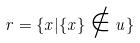<formula> <loc_0><loc_0><loc_500><loc_500>r = \{ x | \{ x \} \notin u \}</formula> 